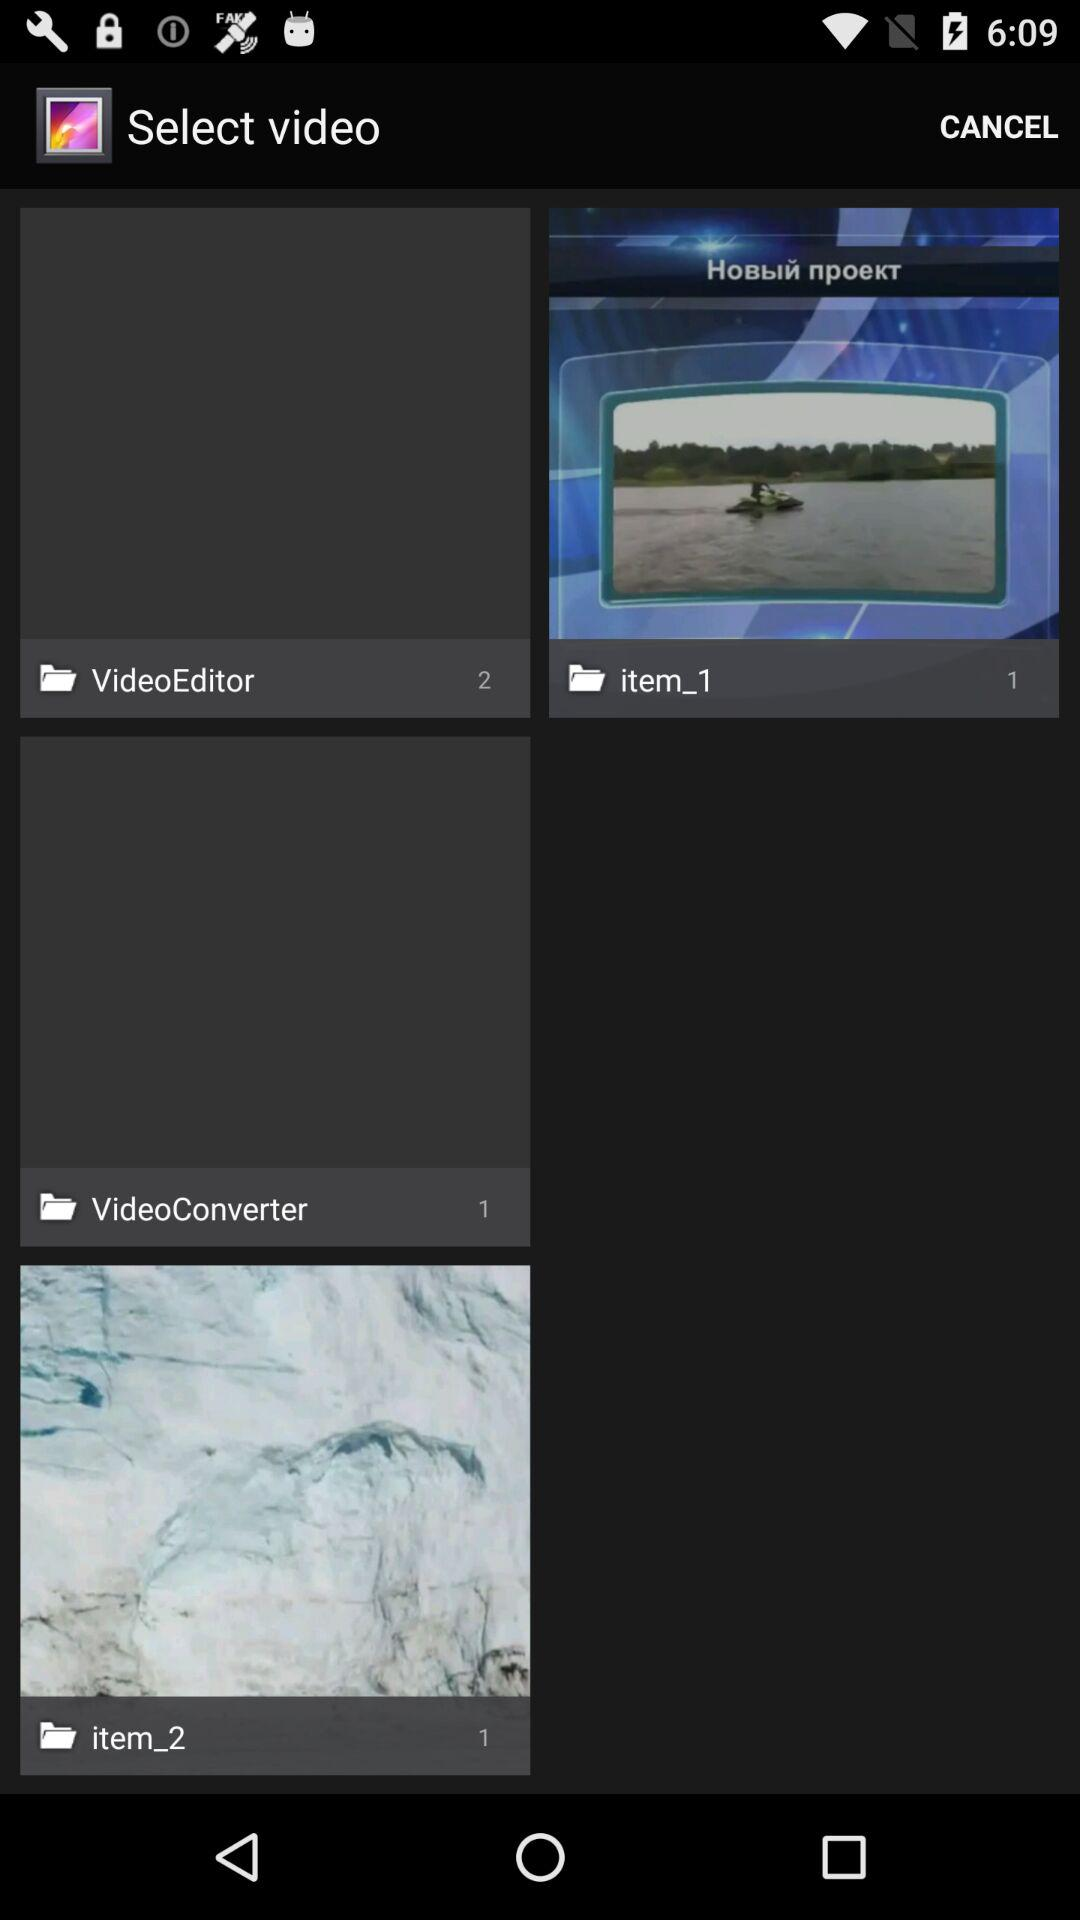How many images are there in the "item_2" album? There is 1 image in the "item_2" album. 